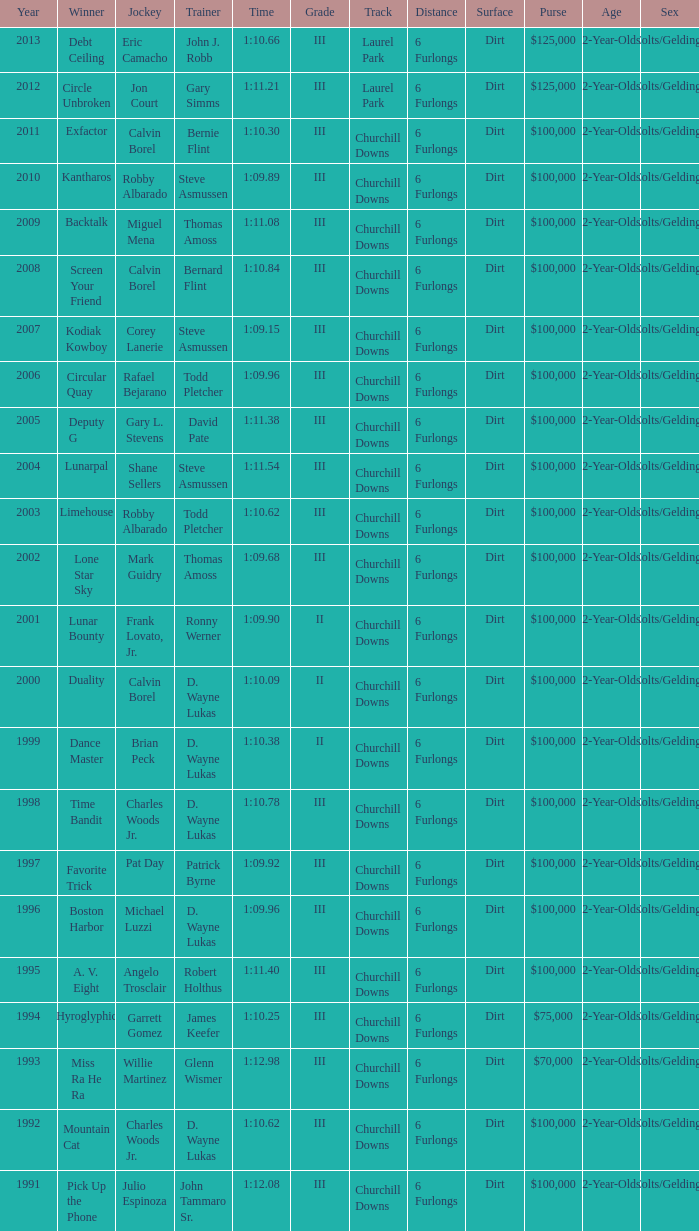Which trainer won the hyroglyphic in a year that was before 2010? James Keefer. 